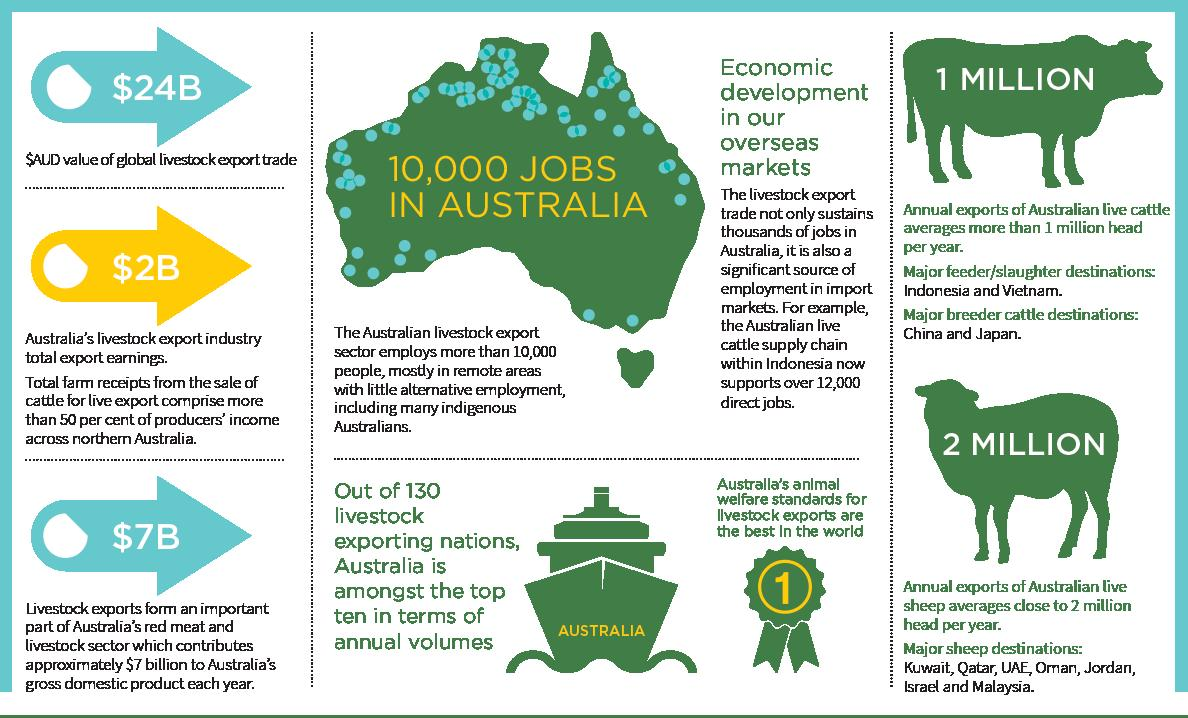Identify some key points in this picture. There are 7 major destinations for sheep. There are two slaughter destinations. There are two destinations for breeder cattle. 